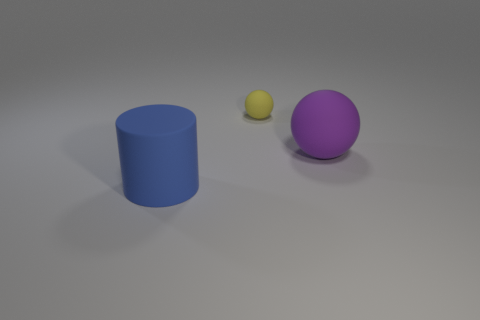Add 2 big rubber cylinders. How many objects exist? 5 Subtract all cylinders. How many objects are left? 2 Subtract 0 purple cubes. How many objects are left? 3 Subtract all big blue cylinders. Subtract all blue matte objects. How many objects are left? 1 Add 3 big blue objects. How many big blue objects are left? 4 Add 2 small gray matte objects. How many small gray matte objects exist? 2 